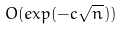Convert formula to latex. <formula><loc_0><loc_0><loc_500><loc_500>O ( e x p ( - c \sqrt { n } ) )</formula> 